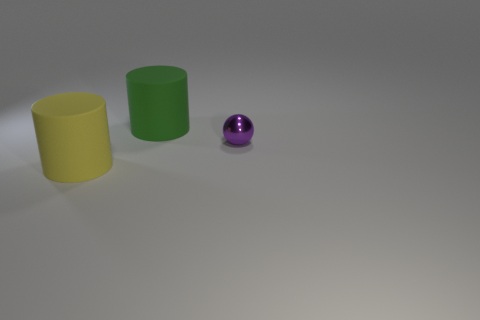Is there any other thing that has the same size as the purple ball?
Keep it short and to the point. No. Are there fewer cyan metal objects than small metallic things?
Keep it short and to the point. Yes. There is a rubber thing that is in front of the big green matte cylinder; is it the same shape as the big rubber object that is behind the small purple object?
Your response must be concise. Yes. What color is the metal ball?
Offer a very short reply. Purple. What number of metallic objects are either cylinders or big cyan cylinders?
Offer a terse response. 0. The other large matte object that is the same shape as the large green matte thing is what color?
Your answer should be compact. Yellow. Is there a green cylinder?
Give a very brief answer. Yes. Does the large cylinder left of the large green matte object have the same material as the cylinder that is behind the tiny purple ball?
Ensure brevity in your answer.  Yes. How many things are things to the left of the green thing or matte cylinders behind the big yellow rubber cylinder?
Keep it short and to the point. 2. There is a thing that is both on the left side of the tiny object and in front of the large green thing; what shape is it?
Make the answer very short. Cylinder. 